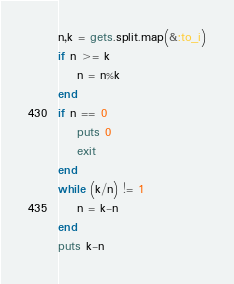Convert code to text. <code><loc_0><loc_0><loc_500><loc_500><_Ruby_>n,k = gets.split.map(&:to_i)
if n >= k 
    n = n%k
end
if n == 0
    puts 0
    exit
end
while (k/n) != 1
    n = k-n
end
puts k-n</code> 